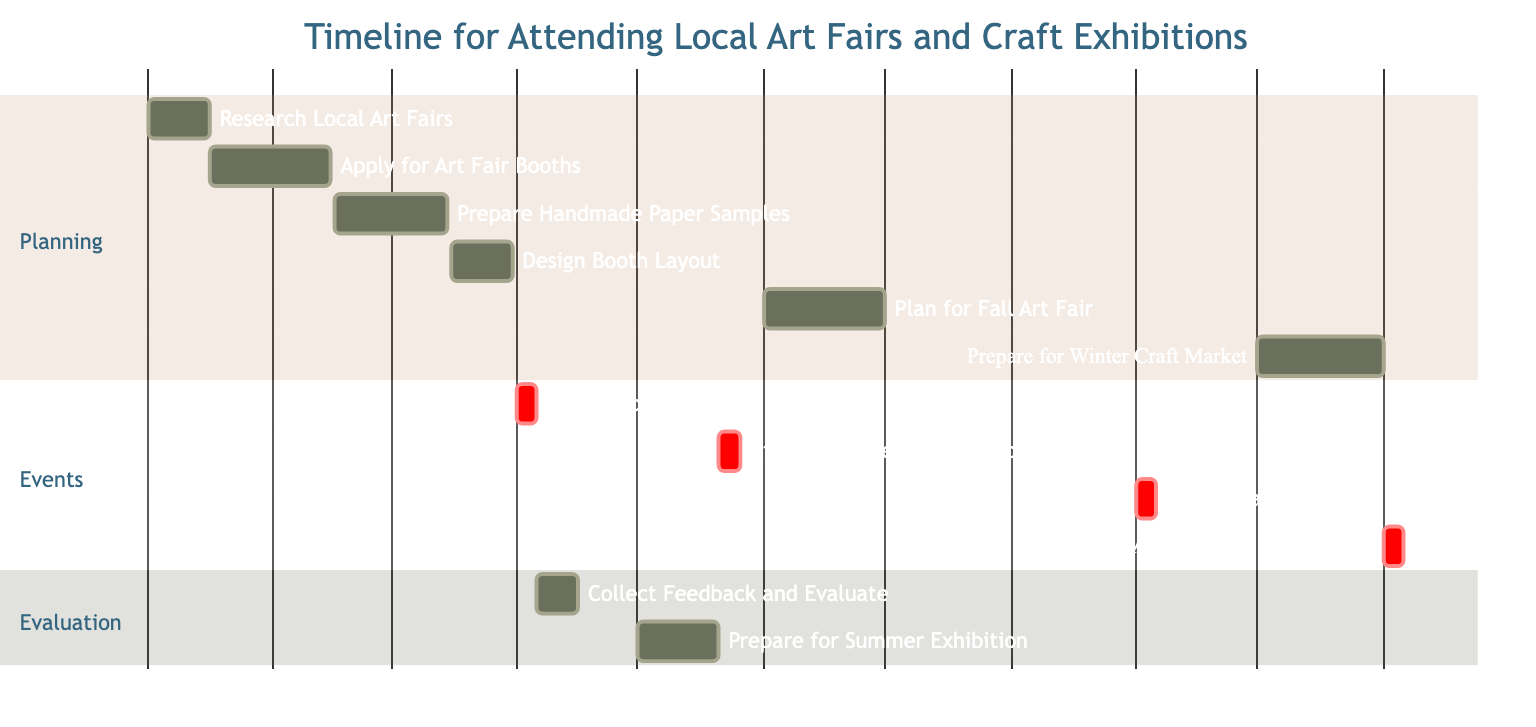What is the duration of the task "Research Local Art Fairs"? The task "Research Local Art Fairs" has a duration listed as 15 days, visible directly in the diagram.
Answer: 15 days When does the "Attend Spring Art Fair" event start? The event "Attend Spring Art Fair" has a start date marked as April 1, 2024, which is specified in the timeline.
Answer: April 1, 2024 How many events are scheduled in the "Events" section? The "Events" section contains four tasks listed under it: "Attend Spring Art Fair," "Attend Summer Craft Exhibition," "Attend Fall Art Fair," and "Attend Winter Craft Market." Counting these gives a total of four events.
Answer: 4 What task follows "Prepare for Winter Craft Market" in the timeline? "Prepare for Winter Craft Market" is a preparatory task, followed by the "Attend Winter Craft Market" task, based on the chronological order in the diagram.
Answer: Attend Winter Craft Market Which task covers the longest duration? By comparing the durations of all tasks, "Prepare for Winter Craft Market" lasts for 31 days, making it the task with the longest duration.
Answer: 31 days What is the end date for "Design Booth Layout"? "Design Booth Layout" is indicated in the diagram to end on March 31, 2024, which is listed under the task details.
Answer: March 31, 2024 Between which two events is the "Collect Feedback and Evaluate Sales" task placed? The "Collect Feedback and Evaluate Sales" task is scheduled to take place between the "Attend Spring Art Fair" and the "Prepare for Summer Craft Exhibition," based on their respective dates.
Answer: Attend Spring Art Fair and Prepare for Summer Craft Exhibition What is the earliest start date among all tasks? The earliest start date listed in the diagram is January 1, 2024, correlating with the task "Research Local Art Fairs."
Answer: January 1, 2024 What is the task ending on November 5, 2024? The task that ends on November 5, 2024, is "Attend Winter Craft Market," as indicated in the timeline.
Answer: Attend Winter Craft Market 